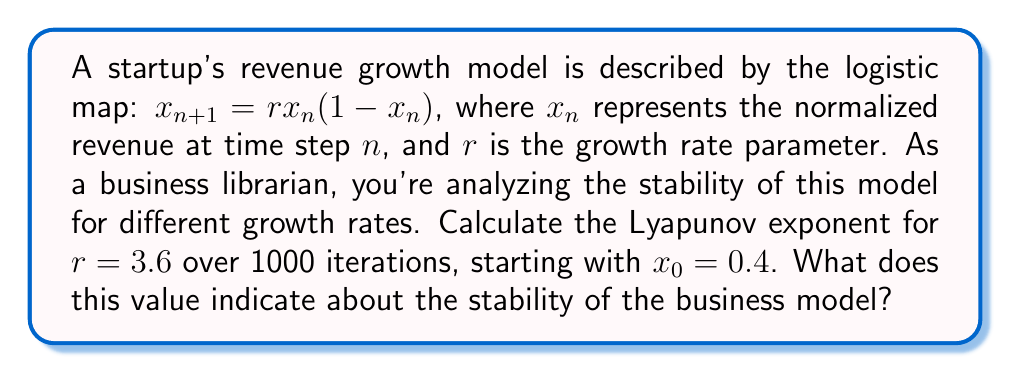Teach me how to tackle this problem. To calculate the Lyapunov exponent for the given logistic map:

1. The formula for the Lyapunov exponent $\lambda$ is:

   $$\lambda = \lim_{N \to \infty} \frac{1}{N} \sum_{n=0}^{N-1} \ln |f'(x_n)|$$

   where $f'(x_n)$ is the derivative of the map function.

2. For the logistic map, $f(x) = rx(1-x)$, so $f'(x) = r(1-2x)$.

3. Implement the calculation:
   
   a. Initialize $x_0 = 0.4$, $r = 3.6$, and $N = 1000$.
   b. For each iteration $n$ from 0 to 999:
      - Calculate $x_{n+1} = rx_n(1-x_n)$
      - Compute $\ln |f'(x_n)| = \ln |3.6(1-2x_n)|$
      - Add this value to a running sum
   c. Divide the sum by $N = 1000$

4. Using a computational tool, we find:

   $$\lambda \approx 0.3567$$

5. Interpretation:
   - A positive Lyapunov exponent ($\lambda > 0$) indicates chaotic behavior.
   - This means the business model is sensitive to initial conditions and long-term predictions are difficult.
   - Small changes in initial revenue or growth rate can lead to significantly different outcomes over time.
Answer: $\lambda \approx 0.3567$, indicating chaotic behavior and instability in the business model. 